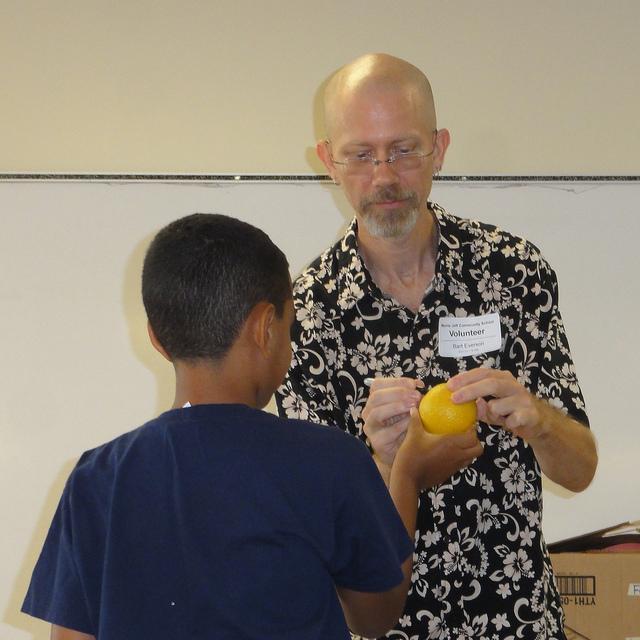How many people are there?
Give a very brief answer. 2. How many of the motorcycles are blue?
Give a very brief answer. 0. 